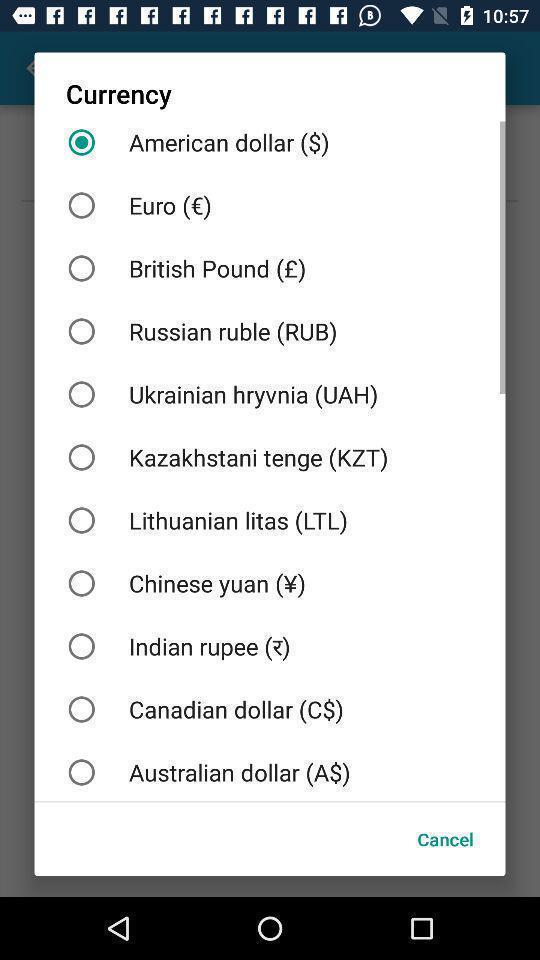Describe the visual elements of this screenshot. Pop-up showing different types of currency. 